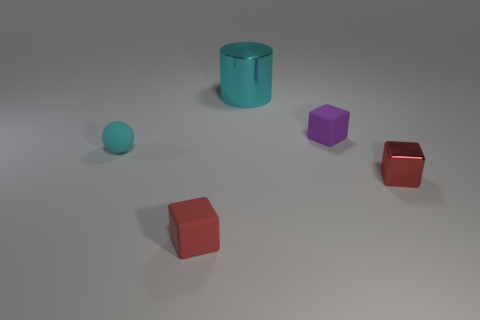Subtract all shiny cubes. How many cubes are left? 2 Subtract 1 cubes. How many cubes are left? 2 Subtract all purple cubes. How many cubes are left? 2 Add 1 large purple matte objects. How many objects exist? 6 Subtract all spheres. How many objects are left? 4 Add 1 tiny purple matte blocks. How many tiny purple matte blocks are left? 2 Add 5 cyan objects. How many cyan objects exist? 7 Subtract 0 gray blocks. How many objects are left? 5 Subtract all gray cylinders. Subtract all yellow cubes. How many cylinders are left? 1 Subtract all gray cylinders. How many brown balls are left? 0 